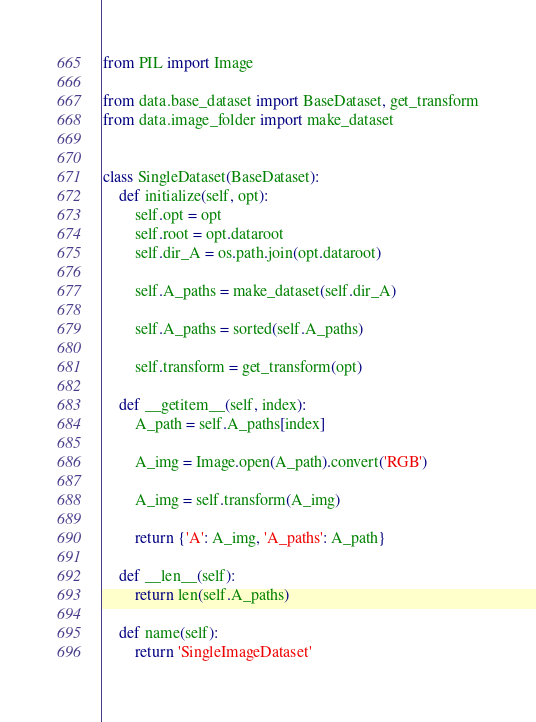<code> <loc_0><loc_0><loc_500><loc_500><_Python_>
from PIL import Image

from data.base_dataset import BaseDataset, get_transform
from data.image_folder import make_dataset


class SingleDataset(BaseDataset):
    def initialize(self, opt):
        self.opt = opt
        self.root = opt.dataroot
        self.dir_A = os.path.join(opt.dataroot)

        self.A_paths = make_dataset(self.dir_A)

        self.A_paths = sorted(self.A_paths)

        self.transform = get_transform(opt)

    def __getitem__(self, index):
        A_path = self.A_paths[index]

        A_img = Image.open(A_path).convert('RGB')

        A_img = self.transform(A_img)

        return {'A': A_img, 'A_paths': A_path}

    def __len__(self):
        return len(self.A_paths)

    def name(self):
        return 'SingleImageDataset'
</code> 